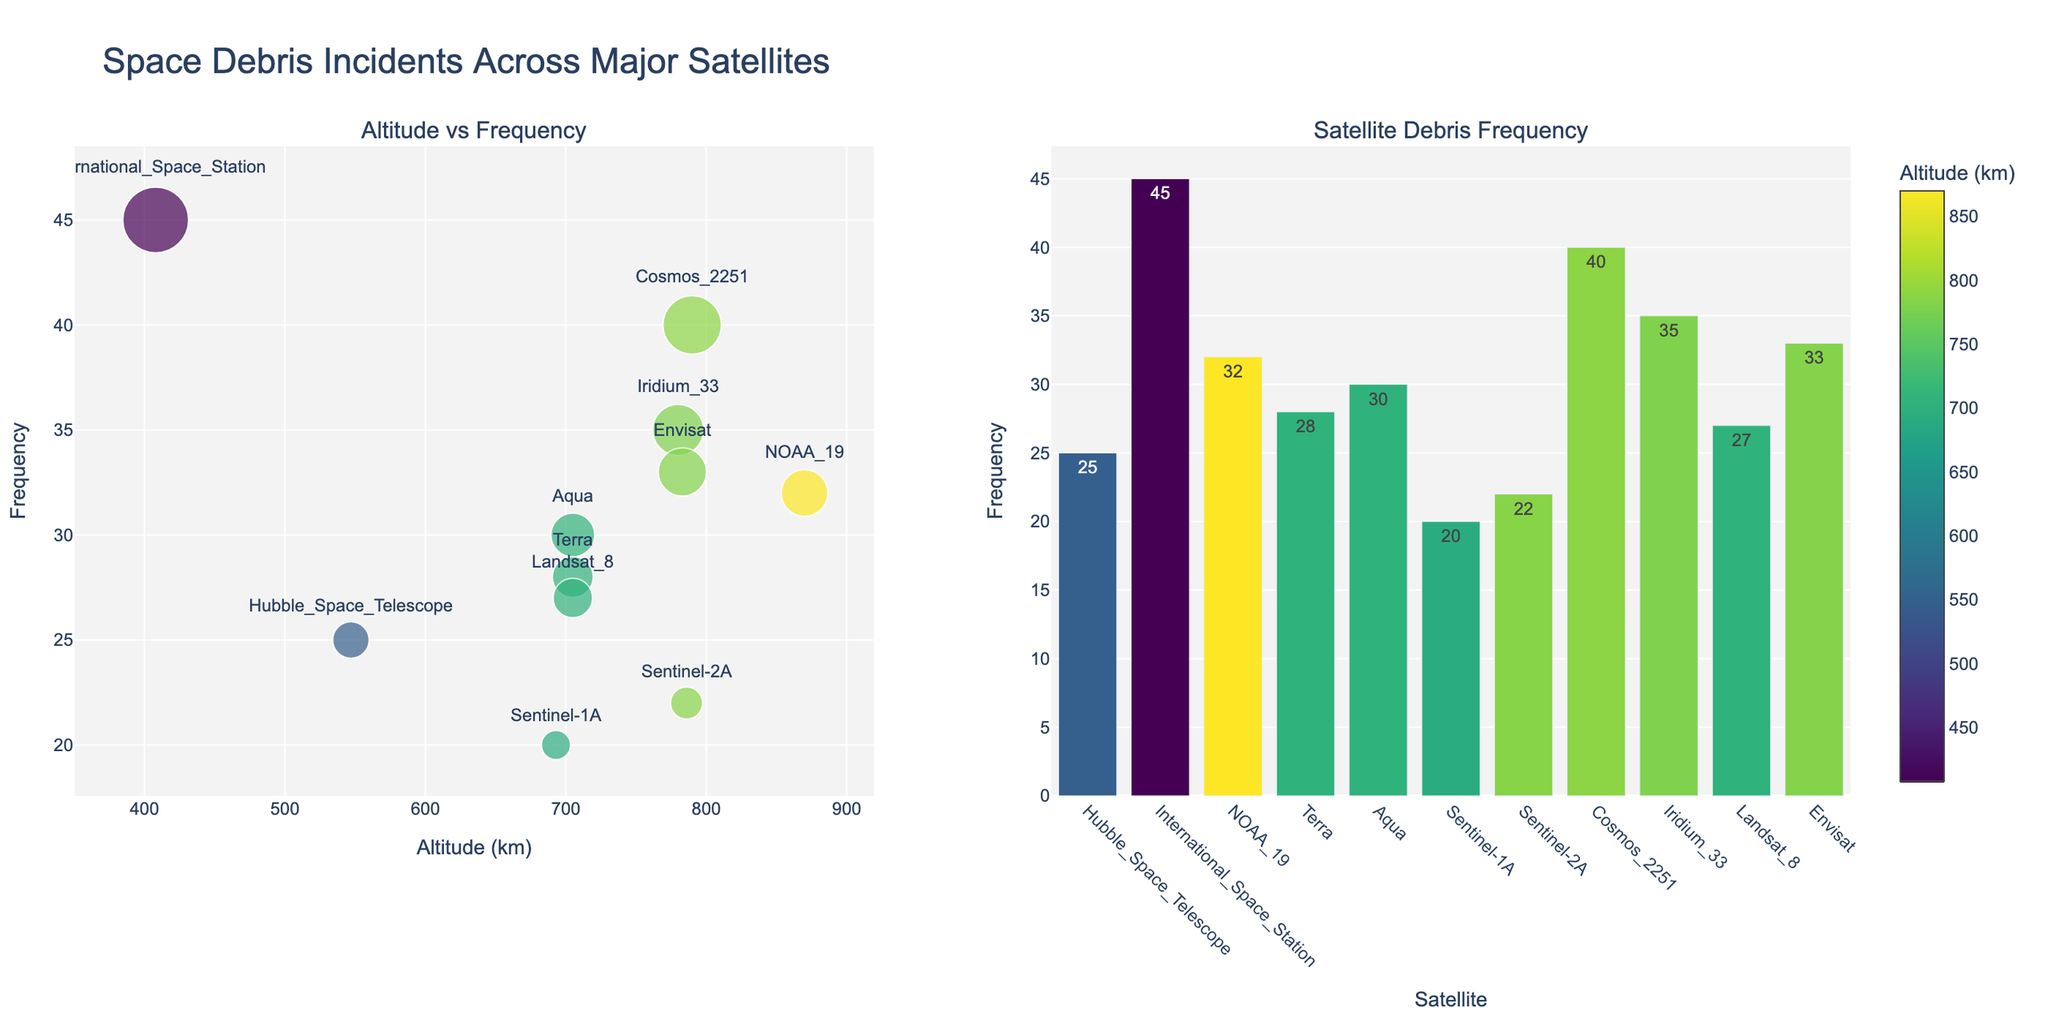How many satellites are plotted in the scatter plot? There are 11 unique data points, each representing a satellite, visible in the scatter plot.
Answer: 11 Which satellite has the highest frequency of debris incidents? The International Space Station has the highest frequency of debris incidents with a value of 45, as indicated by the data point at 408 km altitude and the corresponding information in the hover text.
Answer: International Space Station What is the colorbar title used in the scatter plot? The colorbar title in the scatter plot is "Altitude (km)", which is visible next to the color scale indicating altitude.
Answer: Altitude (km) Which satellite is at the lowest altitude and what is its frequency of debris incidents? The International Space Station is at the lowest altitude of 408 km with a frequency of 45 debris incidents.
Answer: International Space Station, 45 Compare the frequency of debris incidents between Hubble Space Telescope and NOAA-19. Which one has more incidents and by how much? The Hubble Space Telescope has 25 debris incidents, while NOAA-19 has 32. The difference is 32 - 25 = 7 incidents.
Answer: NOAA-19, by 7 What is the average frequency of debris incidents for satellites at an altitude of 705 km? There are three satellites at an altitude of 705 km: Terra, Aqua, and Landsat 8 with frequencies 28, 30, and 27 respectively. The average is (28 + 30 + 27) / 3 = 85 / 3 ≈ 28.33.
Answer: ≈ 28.33 Which satellite has the smallest marker size in the scatter plot, and what does it indicate? Sentinel-1A has the smallest marker size, which indicates it has the lowest frequency of 20 debris incidents among the satellites.
Answer: Sentinel-1A, lowest frequency What is the relationship between altitude and frequency of debris incidents as shown in the scatter plot? There is no clear correlation shown between the altitude and frequency of debris incidents in the scatter plot, as the frequencies vary widely across different altitudes.
Answer: No clear correlation How does the frequency of debris incidents for Cosmos 2251 compare relative to the altitude level? Cosmos 2251 has a high frequency of 40 debris incidents at an altitude of 790 km, which is relatively high in frequency compared to other satellites near this altitude.
Answer: High frequency at high altitude Is there a satellite that appears in both the scatter plot and the bar plot? How can you identify it? All satellites appear in both the scatter plot and bar plot. They can be identified by matching the frequency and altitude from the scatter plot with the frequency in the bar plot.
Answer: Yes, all satellites 